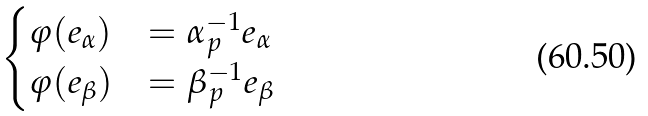<formula> <loc_0><loc_0><loc_500><loc_500>\begin{cases} \varphi ( e _ { \alpha } ) & = \alpha _ { p } ^ { - 1 } e _ { \alpha } \\ \varphi ( e _ { \beta } ) & = \beta _ { p } ^ { - 1 } e _ { \beta } \end{cases}</formula> 